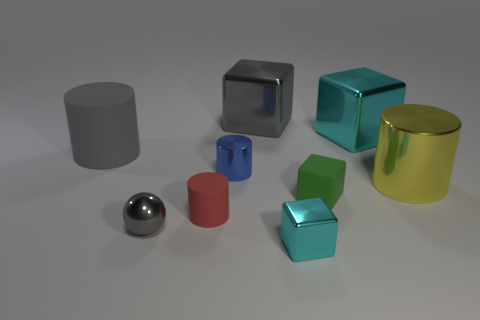Is the metallic sphere the same color as the big rubber thing?
Your response must be concise. Yes. What number of tiny matte objects have the same color as the rubber cube?
Provide a short and direct response. 0. Is the number of tiny metallic spheres greater than the number of brown matte things?
Offer a terse response. Yes. What size is the shiny thing that is behind the tiny shiny ball and to the left of the large gray cube?
Ensure brevity in your answer.  Small. Does the big cylinder left of the green thing have the same material as the tiny block behind the small red cylinder?
Ensure brevity in your answer.  Yes. What shape is the blue thing that is the same size as the gray metallic sphere?
Your answer should be compact. Cylinder. Are there fewer gray matte things than large blue things?
Provide a short and direct response. No. Is there a small matte cube that is in front of the metallic cylinder in front of the small blue shiny thing?
Offer a very short reply. Yes. There is a tiny shiny thing in front of the tiny gray metallic sphere that is to the left of the large yellow object; is there a green cube behind it?
Your answer should be compact. Yes. Does the large gray object right of the small blue object have the same shape as the small metallic object that is on the right side of the blue object?
Provide a succinct answer. Yes. 